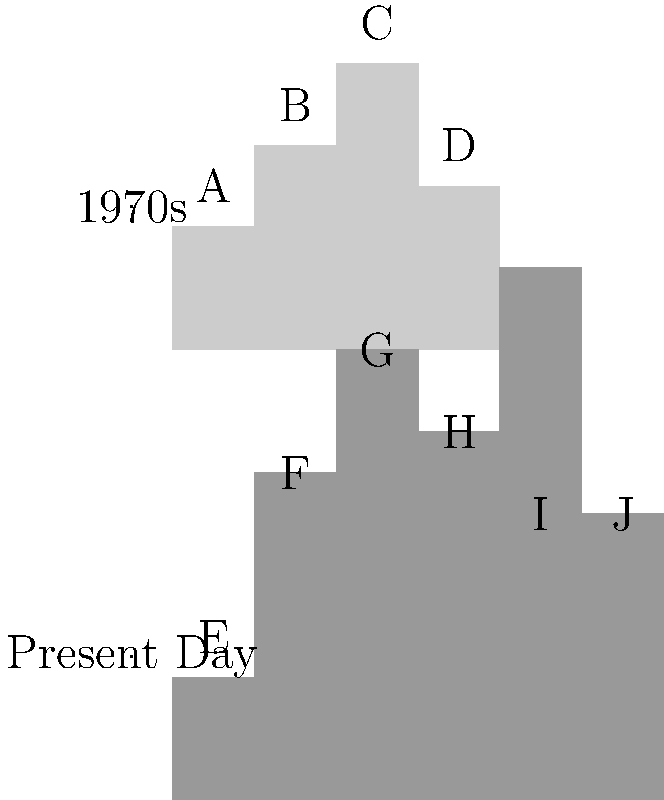Based on the skyline comparison of Madrid from the 1970s to the present day, which building has experienced the most significant height increase? To determine which building has experienced the most significant height increase, we need to compare the heights of corresponding buildings in both skylines:

1. Building A (1970s) corresponds to building E (present day):
   Increase = 30 units (no change)

2. Building B (1970s) corresponds to building F (present day):
   Increase = 80 - 50 = 30 units

3. Building C (1970s) corresponds to building G (present day):
   Increase = 110 - 70 = 40 units

4. Building D (1970s) corresponds to building H (present day):
   Increase = 90 - 40 = 50 units

5. New buildings I and J have been added to the skyline, but they don't represent increases in existing structures.

Comparing the increases, we can see that building D (corresponding to H in the present day) has experienced the most significant height increase of 50 units.
Answer: Building D 